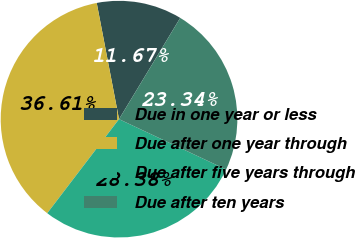Convert chart. <chart><loc_0><loc_0><loc_500><loc_500><pie_chart><fcel>Due in one year or less<fcel>Due after one year through<fcel>Due after five years through<fcel>Due after ten years<nl><fcel>11.67%<fcel>36.61%<fcel>28.38%<fcel>23.34%<nl></chart> 